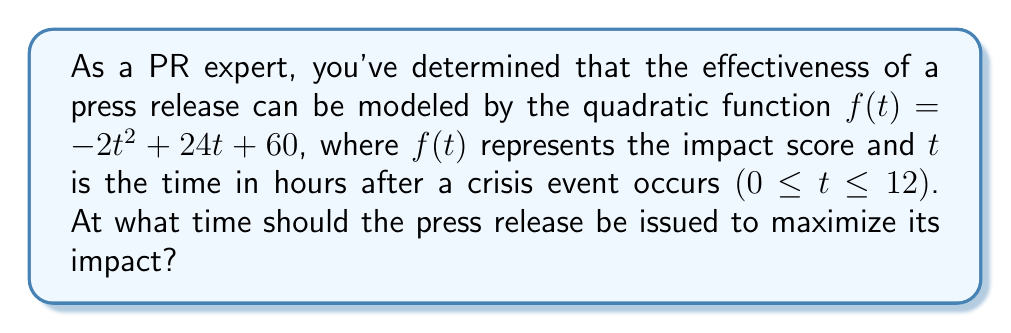Give your solution to this math problem. To find the optimal timing for the press release, we need to determine the maximum value of the quadratic function $f(t) = -2t^2 + 24t + 60$.

1) The quadratic function is in the form $f(t) = at^2 + bt + c$, where:
   $a = -2$
   $b = 24$
   $c = 60$

2) For a quadratic function, the t-coordinate of the vertex represents the point where the function reaches its maximum (when $a < 0$) or minimum (when $a > 0$).

3) The formula for the t-coordinate of the vertex is: $t = -\frac{b}{2a}$

4) Substituting our values:
   $t = -\frac{24}{2(-2)} = -\frac{24}{-4} = 6$

5) Therefore, the function reaches its maximum when $t = 6$ hours.

6) To verify, we can calculate the impact score at $t = 6$:
   $f(6) = -2(6)^2 + 24(6) + 60$
   $    = -2(36) + 144 + 60$
   $    = -72 + 144 + 60$
   $    = 132$

This is indeed the maximum value of the function within the given domain.
Answer: The press release should be issued 6 hours after the crisis event occurs to maximize its impact. 